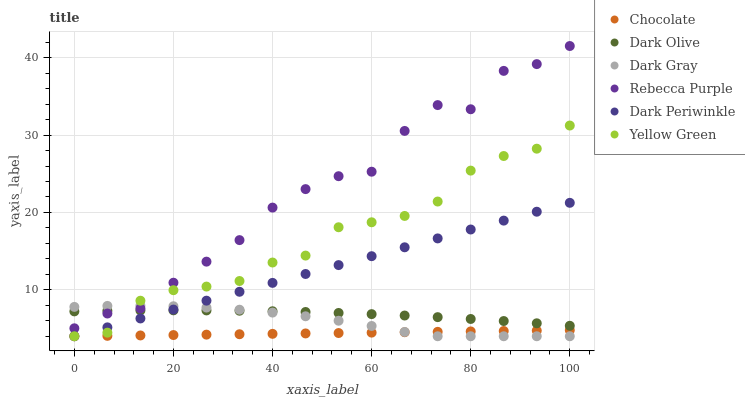Does Chocolate have the minimum area under the curve?
Answer yes or no. Yes. Does Rebecca Purple have the maximum area under the curve?
Answer yes or no. Yes. Does Dark Olive have the minimum area under the curve?
Answer yes or no. No. Does Dark Olive have the maximum area under the curve?
Answer yes or no. No. Is Chocolate the smoothest?
Answer yes or no. Yes. Is Rebecca Purple the roughest?
Answer yes or no. Yes. Is Dark Olive the smoothest?
Answer yes or no. No. Is Dark Olive the roughest?
Answer yes or no. No. Does Yellow Green have the lowest value?
Answer yes or no. Yes. Does Dark Olive have the lowest value?
Answer yes or no. No. Does Rebecca Purple have the highest value?
Answer yes or no. Yes. Does Dark Olive have the highest value?
Answer yes or no. No. Is Chocolate less than Dark Olive?
Answer yes or no. Yes. Is Rebecca Purple greater than Chocolate?
Answer yes or no. Yes. Does Rebecca Purple intersect Dark Gray?
Answer yes or no. Yes. Is Rebecca Purple less than Dark Gray?
Answer yes or no. No. Is Rebecca Purple greater than Dark Gray?
Answer yes or no. No. Does Chocolate intersect Dark Olive?
Answer yes or no. No. 